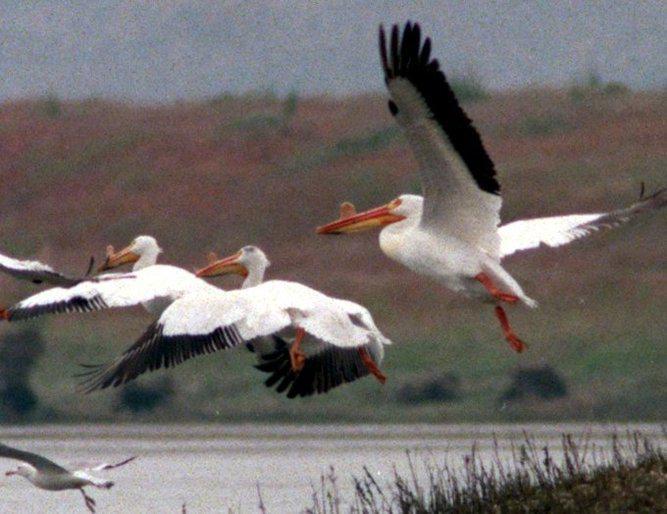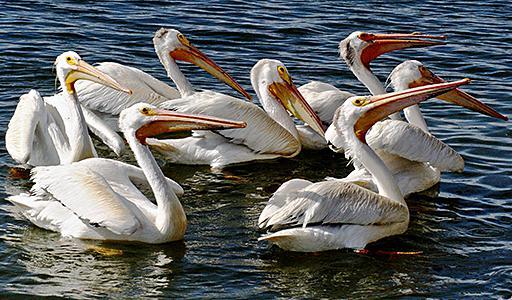The first image is the image on the left, the second image is the image on the right. For the images shown, is this caption "there is a single pelican in flight" true? Answer yes or no. No. The first image is the image on the left, the second image is the image on the right. Examine the images to the left and right. Is the description "The right image contains at least four birds." accurate? Answer yes or no. Yes. 